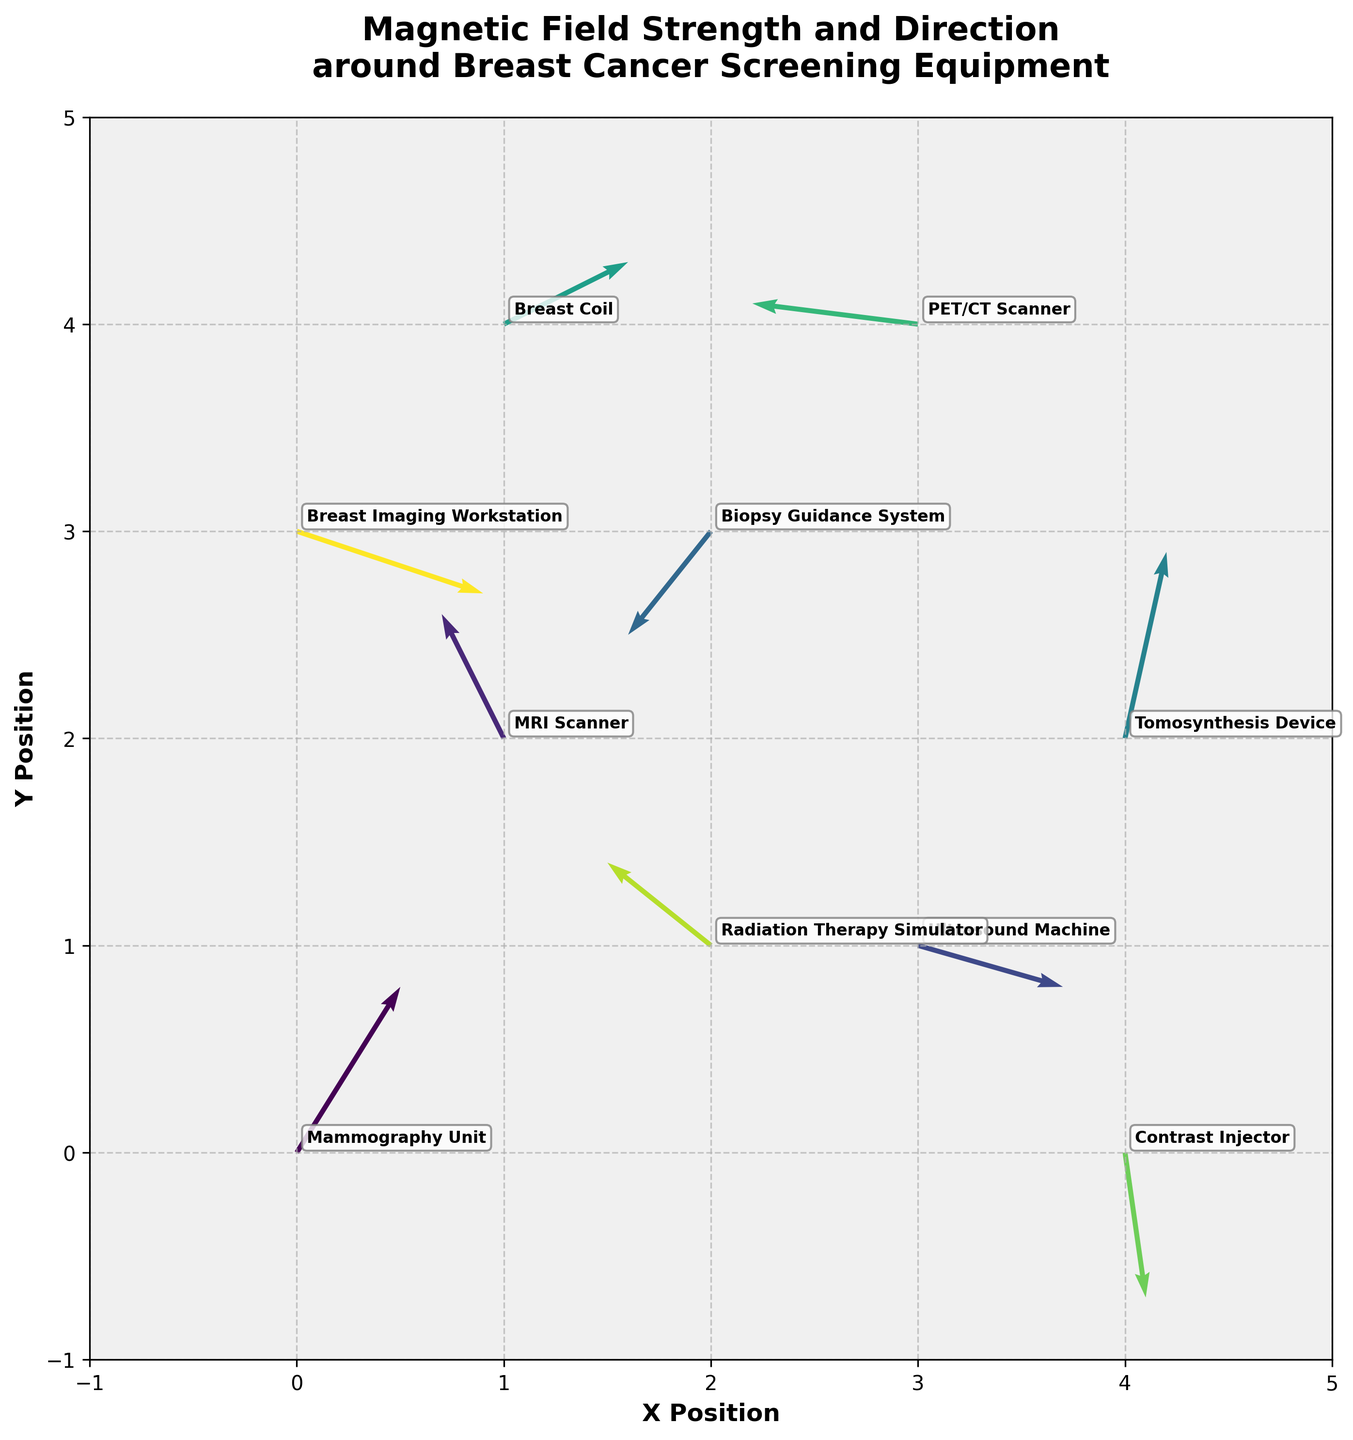What's the title of the plot? The title is located at the top of the plot and helps to provide a context about the data being visualized. The title here is "Magnetic Field Strength and Direction around Breast Cancer Screening Equipment."
Answer: Magnetic Field Strength and Direction around Breast Cancer Screening Equipment How many different pieces of equipment are represented in the plot? Count the number of unique equipment labels annotated on the plot. Each label corresponds to a different piece of equipment.
Answer: 10 Which equipment shows the strongest magnetic field vector? The strength of a magnetic field vector can be estimated by the length of the arrow. The Breast Imaging Workstation has the longest arrow, indicating the strongest field.
Answer: Breast Imaging Workstation What are the coordinates of the MRI Scanner? To find this, look for the annotation labeled "MRI Scanner" and note the (x, y) coordinates next to it. The coordinates are (1, 2).
Answer: (1, 2) Which equipment is located at the highest y-position? Check the y-coordinate annotation of each equipment. The Breast Coil is placed at (1, 4), which is the highest y-coordinate.
Answer: Breast Coil How many equipment annotations have arrows pointing in the negative x-direction? Identify the arrows that have a negative u-component (pointing left). The Biopsy Guidance System, MRI Scanner, Radiation Therapy Simulator, and PET/CT Scanner all have arrows pointing in the negative x-direction.
Answer: 4 Which two pieces of equipment have arrows pointing almost directly downward? This involves identifying arrows with a significant negative v-component while u-component is minimal. The Contrast Injector and Tomosynthesis Device have arrows mostly pointing downwards.
Answer: Contrast Injector, Tomosynthesis Device Do any pieces of equipment have vectors pointing northeast? Vectors pointing northeast have both positive u and v components. The Mammography Unit fits this description with its arrow pointing in the northeast direction.
Answer: Mammography Unit Which piece of equipment's vector is closest to the point (4, 0)? Look for the equipment label closest to the coordinate (4, 0). The Contrast Injector is located at (4, 0).
Answer: Contrast Injector 